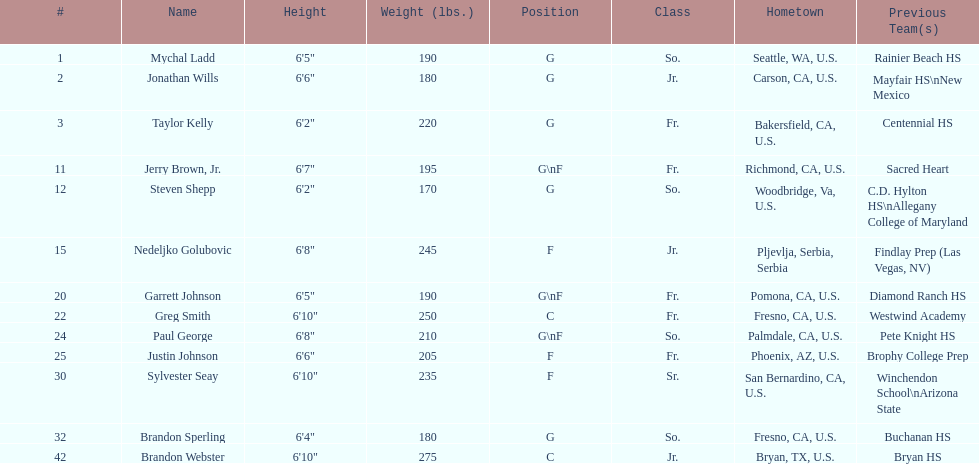Which player previously played for sacred heart? Jerry Brown, Jr. 